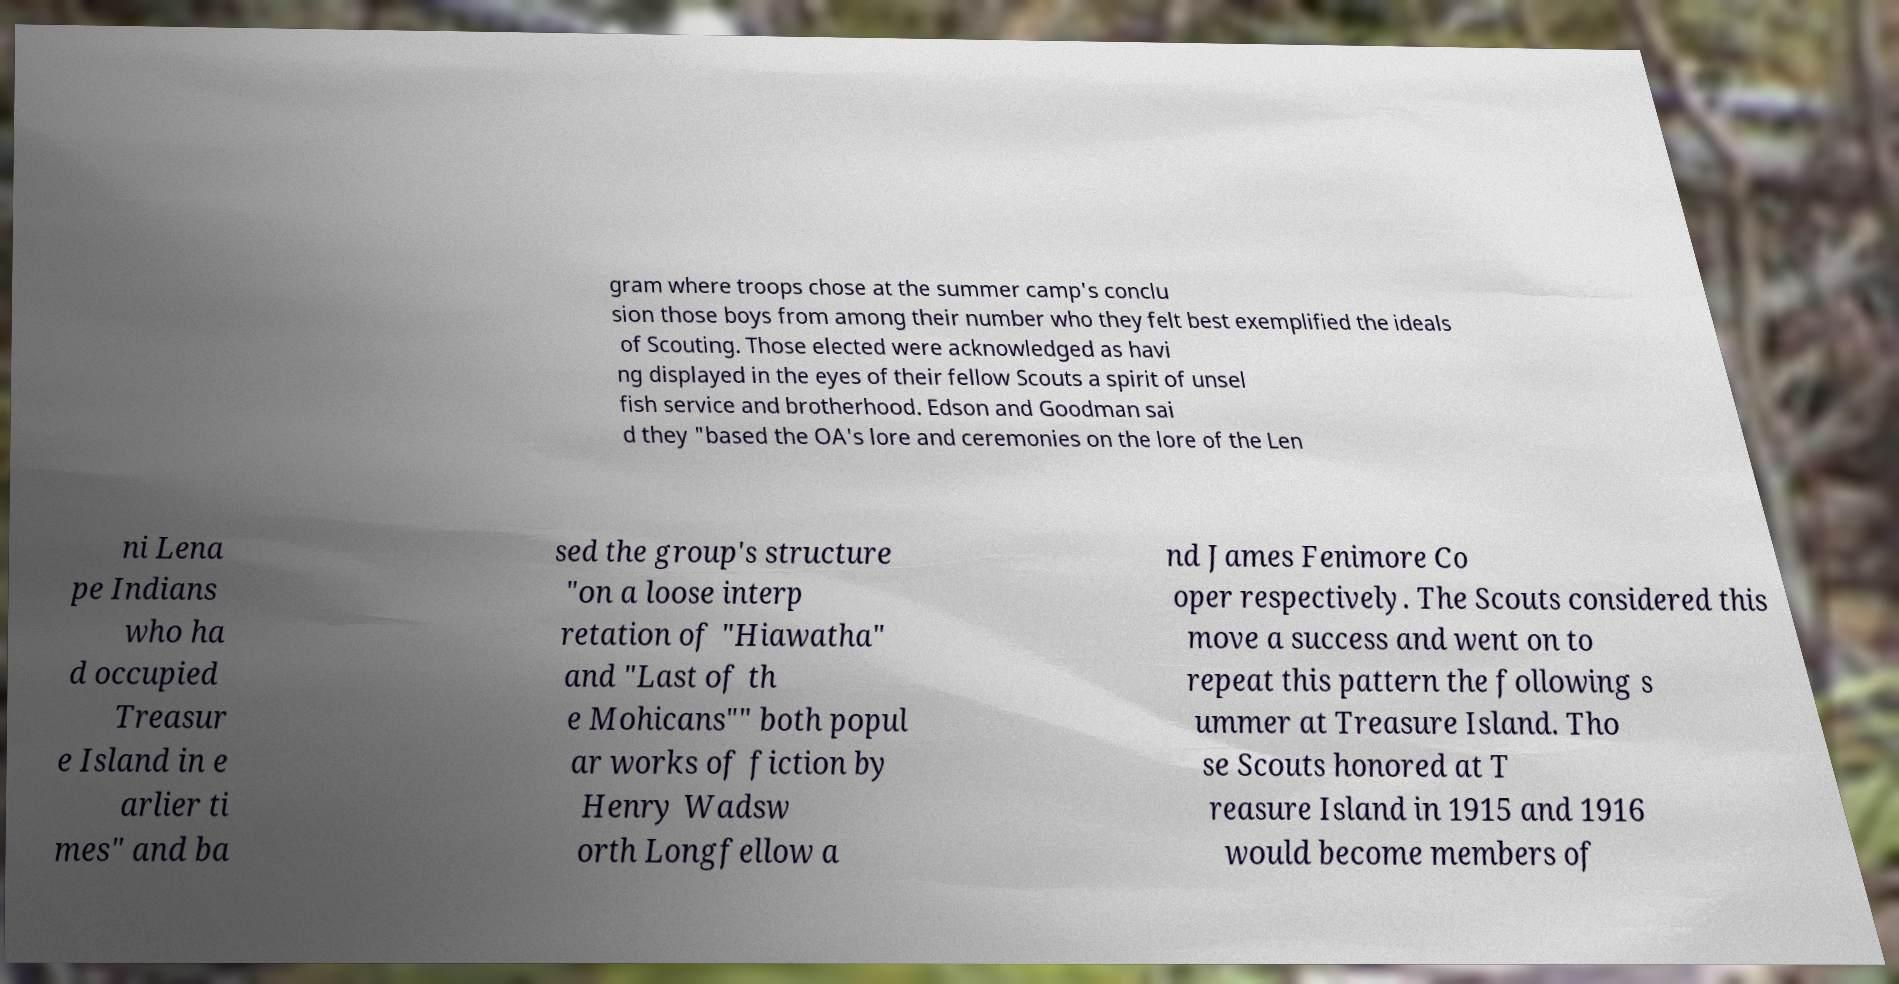Can you read and provide the text displayed in the image?This photo seems to have some interesting text. Can you extract and type it out for me? gram where troops chose at the summer camp's conclu sion those boys from among their number who they felt best exemplified the ideals of Scouting. Those elected were acknowledged as havi ng displayed in the eyes of their fellow Scouts a spirit of unsel fish service and brotherhood. Edson and Goodman sai d they "based the OA's lore and ceremonies on the lore of the Len ni Lena pe Indians who ha d occupied Treasur e Island in e arlier ti mes" and ba sed the group's structure "on a loose interp retation of "Hiawatha" and "Last of th e Mohicans"" both popul ar works of fiction by Henry Wadsw orth Longfellow a nd James Fenimore Co oper respectively. The Scouts considered this move a success and went on to repeat this pattern the following s ummer at Treasure Island. Tho se Scouts honored at T reasure Island in 1915 and 1916 would become members of 